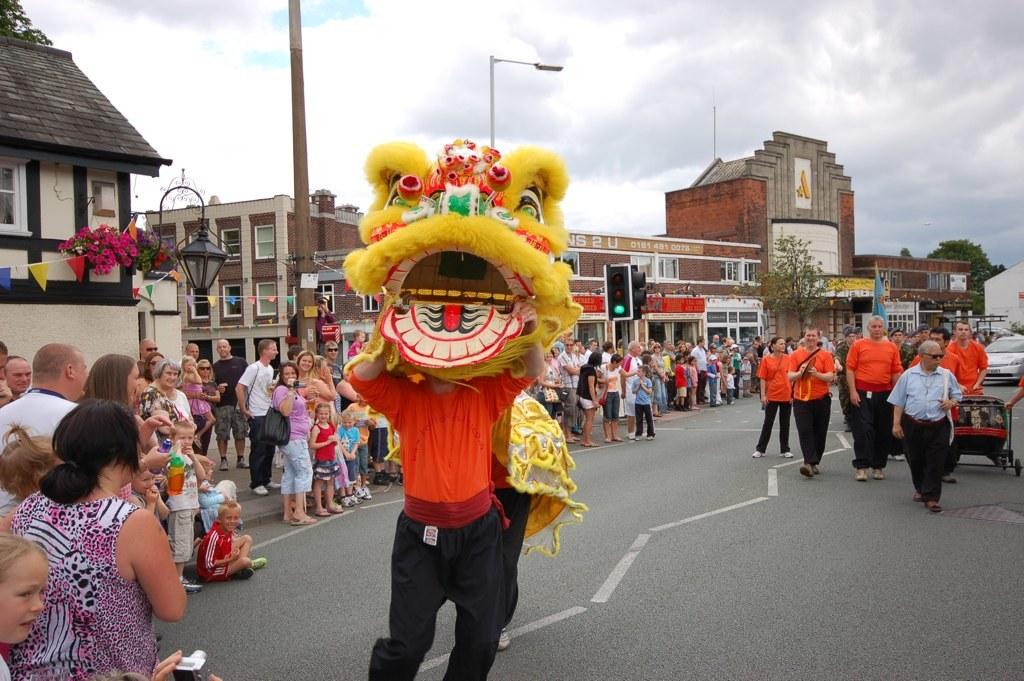What is happening on the road in the image? There are people on the road in the image. What can be seen on the left side of the image? There are houses on the left side of the image. What is visible in the sky in the background of the image? There are clouds visible in the sky in the background of the image. Where is the cannon located in the image? There is no cannon present in the image. What type of calculations can be performed using the calculator in the image? There is no calculator present in the image. 